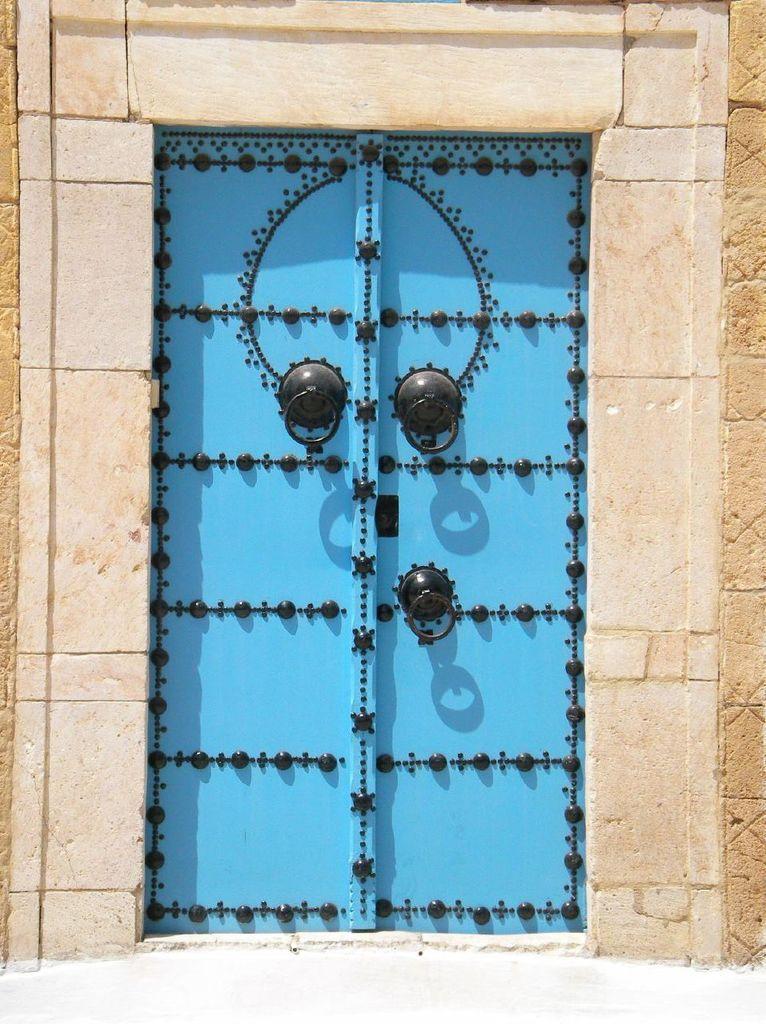Please provide a concise description of this image. In this image we can see a wall and blue door. 